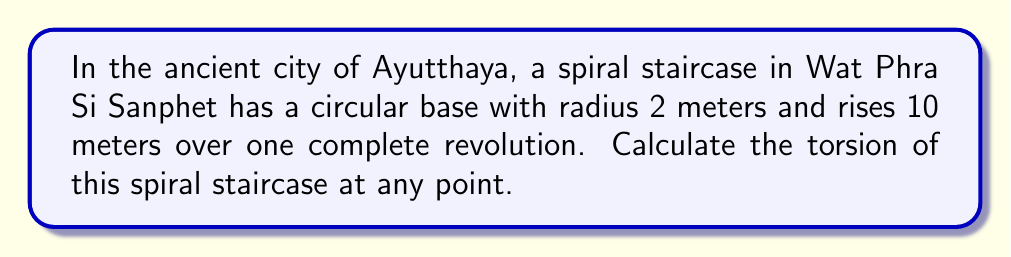Give your solution to this math problem. To calculate the torsion of the spiral staircase, we'll follow these steps:

1) First, let's parameterize the spiral staircase. If we consider the staircase as a helix, we can represent it as:

   $r(t) = (2\cos(t), 2\sin(t), \frac{5t}{\pi})$

   where $t$ is the parameter (0 ≤ t ≤ 2π for one complete revolution).

2) To find the torsion, we need to calculate $r'(t)$, $r''(t)$, and $r'''(t)$:

   $r'(t) = (-2\sin(t), 2\cos(t), \frac{5}{\pi})$
   $r''(t) = (-2\cos(t), -2\sin(t), 0)$
   $r'''(t) = (2\sin(t), -2\cos(t), 0)$

3) The torsion τ is given by the formula:

   $$\tau = \frac{(r' \times r'') \cdot r'''}{|r' \times r''|^2}$$

4) Let's calculate $r' \times r''$:

   $$r' \times r'' = \begin{vmatrix} 
   i & j & k \\
   -2\sin(t) & 2\cos(t) & \frac{5}{\pi} \\
   -2\cos(t) & -2\sin(t) & 0
   \end{vmatrix}$$

   $= (-\frac{10}{\pi}\sin(t), -\frac{10}{\pi}\cos(t), 4)$

5) Now, $(r' \times r'') \cdot r'''$:

   $(-\frac{10}{\pi}\sin(t), -\frac{10}{\pi}\cos(t), 4) \cdot (2\sin(t), -2\cos(t), 0) = \frac{20}{\pi}$

6) Calculate $|r' \times r''|^2$:

   $(-\frac{10}{\pi}\sin(t))^2 + (-\frac{10}{\pi}\cos(t))^2 + 4^2 = \frac{100}{\pi^2} + 16$

7) Finally, the torsion:

   $$\tau = \frac{\frac{20}{\pi}}{\frac{100}{\pi^2} + 16} = \frac{20\pi}{100 + 16\pi^2}$$

This value is constant, independent of $t$, which means the torsion is the same at every point of the spiral staircase.
Answer: $\frac{20\pi}{100 + 16\pi^2}$ 